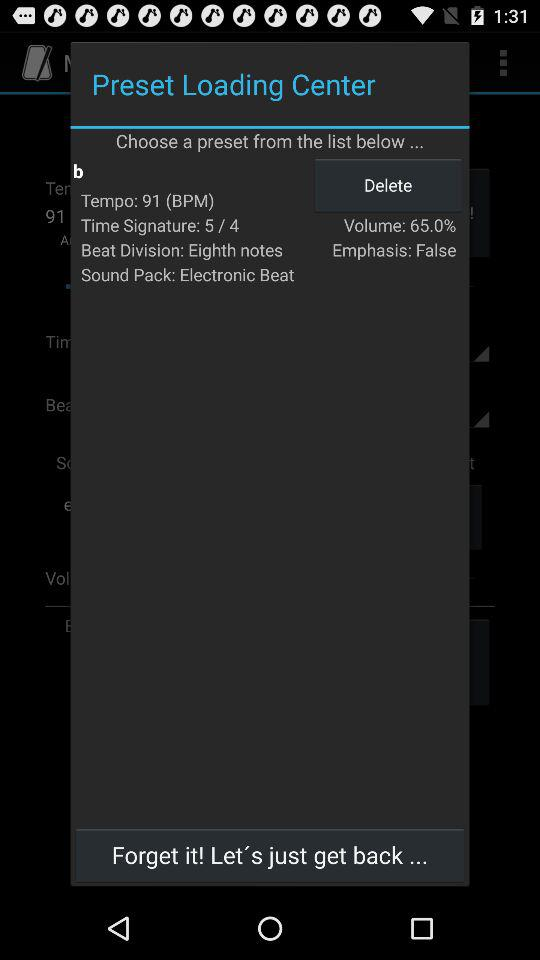What's the beat division? The beat division is "Eighth notes". 